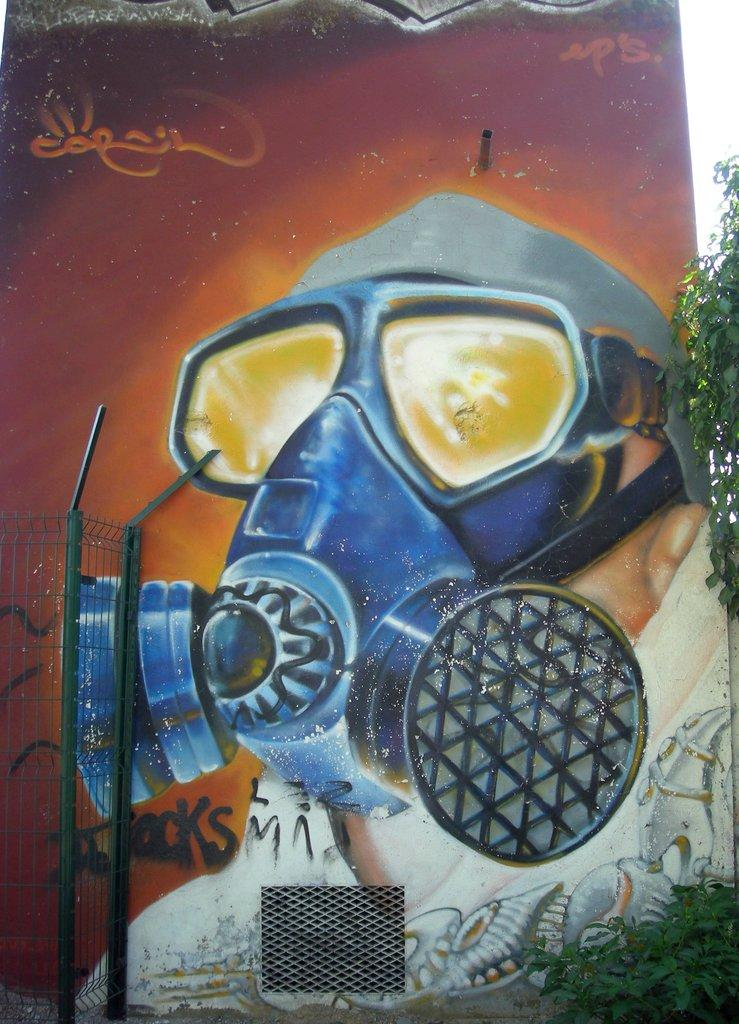What is hanging on the wall in the image? There is a painting on the wall in the image. What can be seen on the left side of the image? There is a grill on the left side of the image. What type of vegetation is on the right side of the image? There are trees on the right side of the image. What is located at the bottom of the image? There are plants at the bottom of the image. Is there any evidence of a holiday celebration in the image? There is no indication of a holiday celebration in the image. Is there any snow visible in the image? There is no snow present in the image. 